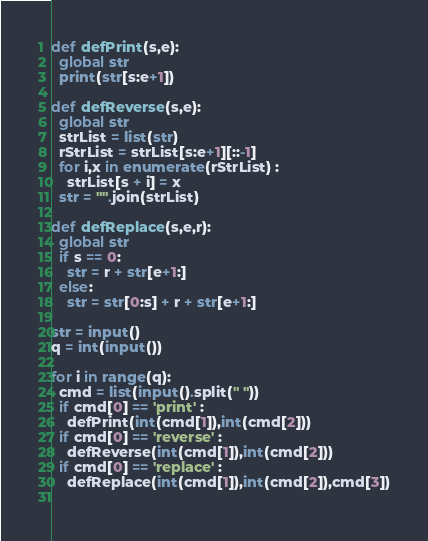<code> <loc_0><loc_0><loc_500><loc_500><_Python_>def defPrint(s,e):
  global str
  print(str[s:e+1])

def defReverse(s,e):
  global str
  strList = list(str)
  rStrList = strList[s:e+1][::-1]
  for i,x in enumerate(rStrList) :
    strList[s + i] = x
  str = "".join(strList)  
  
def defReplace(s,e,r):
  global str
  if s == 0:
    str = r + str[e+1:]
  else:
    str = str[0:s] + r + str[e+1:]

str = input()
q = int(input())

for i in range(q):
  cmd = list(input().split(" "))
  if cmd[0] == 'print' :
    defPrint(int(cmd[1]),int(cmd[2]))
  if cmd[0] == 'reverse' :
    defReverse(int(cmd[1]),int(cmd[2]))
  if cmd[0] == 'replace' :
    defReplace(int(cmd[1]),int(cmd[2]),cmd[3])
  
</code> 